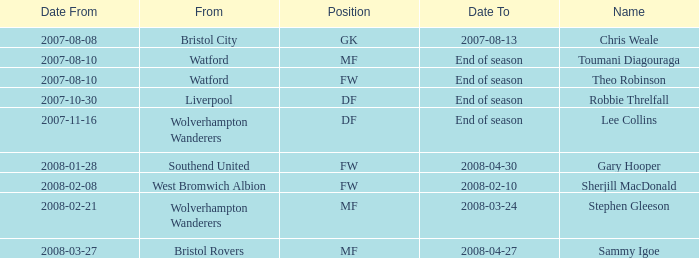Where was the player from who had the position of DF, who started 2007-10-30? Liverpool. 